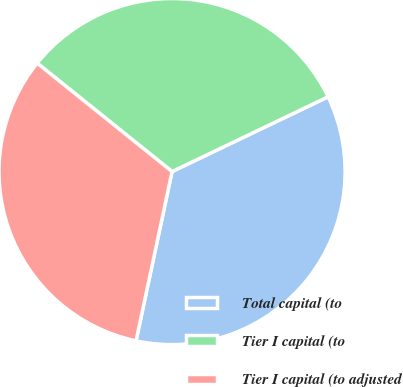Convert chart to OTSL. <chart><loc_0><loc_0><loc_500><loc_500><pie_chart><fcel>Total capital (to<fcel>Tier I capital (to<fcel>Tier I capital (to adjusted<nl><fcel>35.45%<fcel>32.11%<fcel>32.44%<nl></chart> 